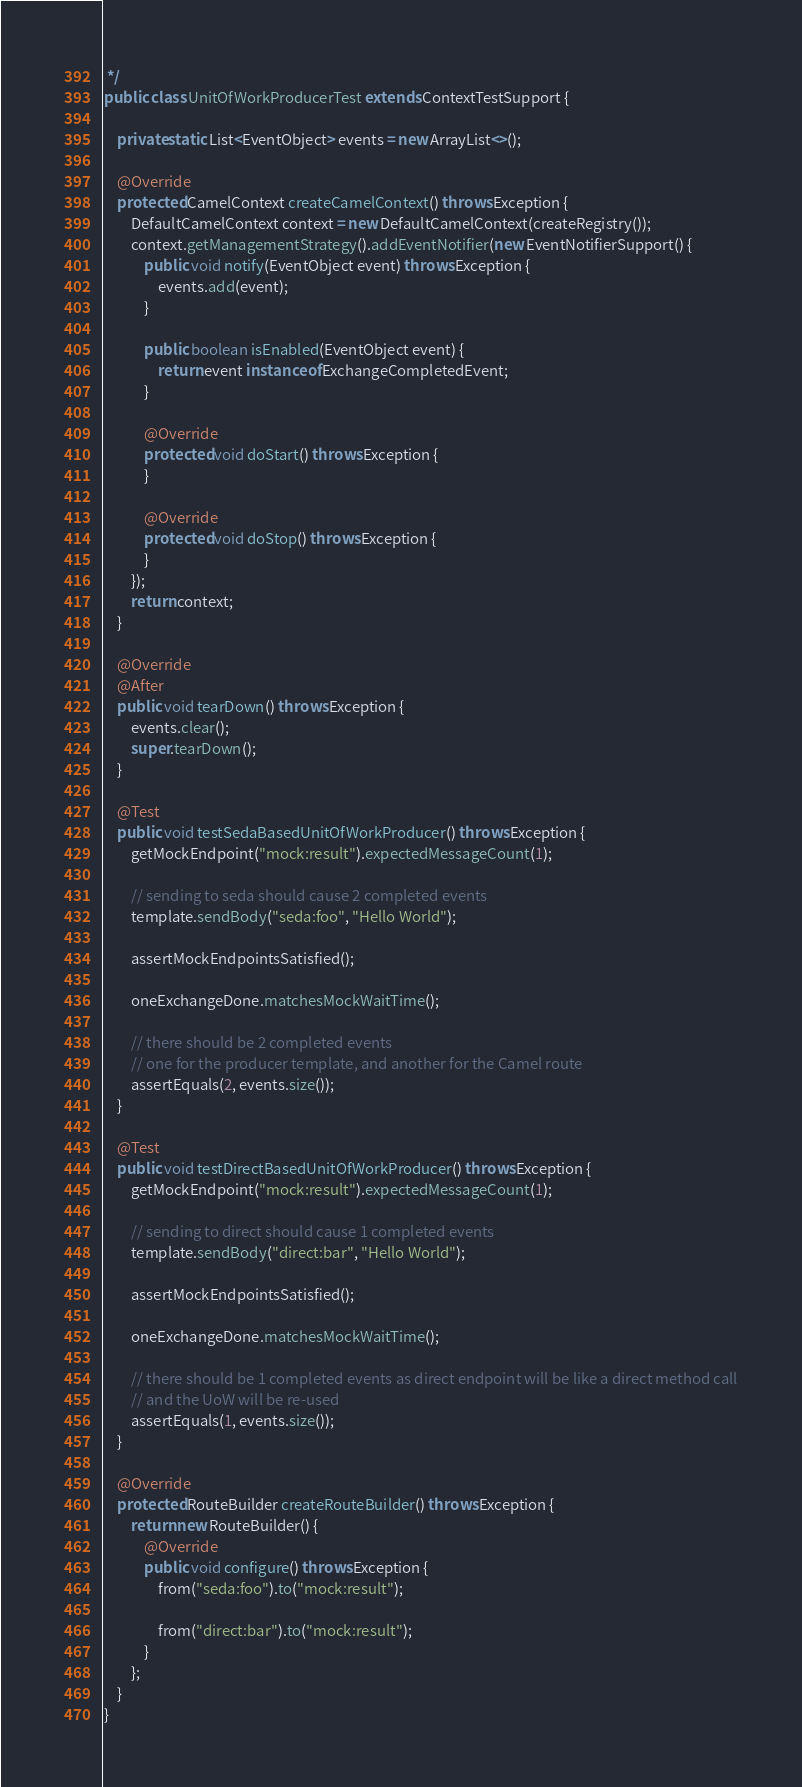Convert code to text. <code><loc_0><loc_0><loc_500><loc_500><_Java_> */
public class UnitOfWorkProducerTest extends ContextTestSupport {

    private static List<EventObject> events = new ArrayList<>();

    @Override
    protected CamelContext createCamelContext() throws Exception {
        DefaultCamelContext context = new DefaultCamelContext(createRegistry());
        context.getManagementStrategy().addEventNotifier(new EventNotifierSupport() {
            public void notify(EventObject event) throws Exception {
                events.add(event);
            }

            public boolean isEnabled(EventObject event) {
                return event instanceof ExchangeCompletedEvent;
            }

            @Override
            protected void doStart() throws Exception {
            }

            @Override
            protected void doStop() throws Exception {
            }
        });
        return context;
    }

    @Override
    @After
    public void tearDown() throws Exception {
        events.clear();
        super.tearDown();
    }

    @Test
    public void testSedaBasedUnitOfWorkProducer() throws Exception {
        getMockEndpoint("mock:result").expectedMessageCount(1);

        // sending to seda should cause 2 completed events
        template.sendBody("seda:foo", "Hello World");

        assertMockEndpointsSatisfied();

        oneExchangeDone.matchesMockWaitTime();

        // there should be 2 completed events
        // one for the producer template, and another for the Camel route
        assertEquals(2, events.size());
    }

    @Test
    public void testDirectBasedUnitOfWorkProducer() throws Exception {
        getMockEndpoint("mock:result").expectedMessageCount(1);

        // sending to direct should cause 1 completed events
        template.sendBody("direct:bar", "Hello World");

        assertMockEndpointsSatisfied();

        oneExchangeDone.matchesMockWaitTime();

        // there should be 1 completed events as direct endpoint will be like a direct method call
        // and the UoW will be re-used
        assertEquals(1, events.size());
    }

    @Override
    protected RouteBuilder createRouteBuilder() throws Exception {
        return new RouteBuilder() {
            @Override
            public void configure() throws Exception {
                from("seda:foo").to("mock:result");

                from("direct:bar").to("mock:result");
            }
        };
    }
}
</code> 